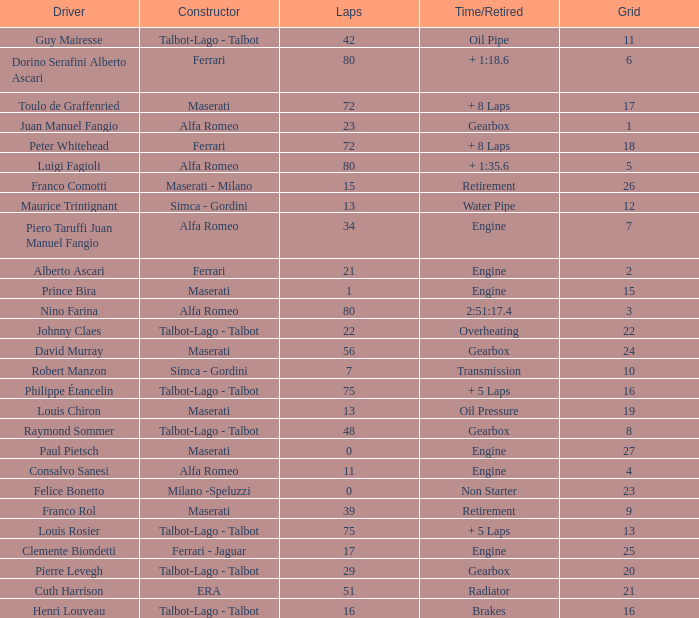When grid is less than 7, laps are greater than 17, and time/retired is + 1:35.6, who is the constructor? Alfa Romeo. 